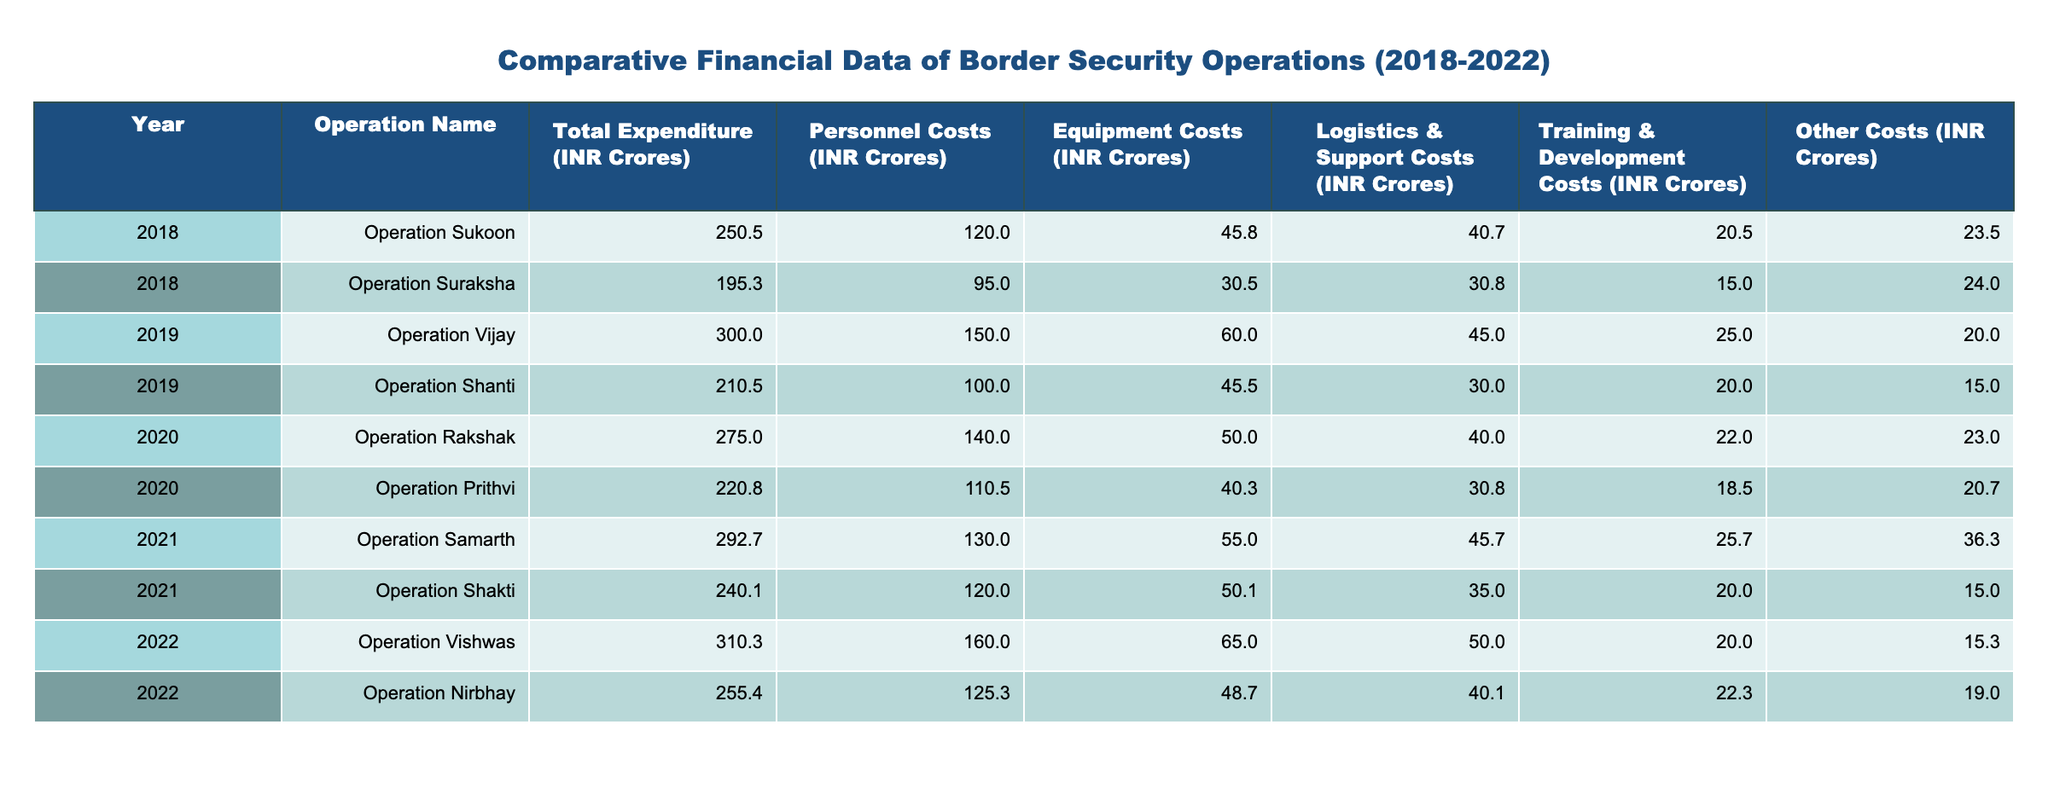What was the total expenditure for Operation Sukoon in 2018? The table indicates that for Operation Sukoon in the year 2018, the total expenditure is listed as 250.5 INR Crores.
Answer: 250.5 INR Crores Which operation had the highest personnel costs in 2022? Reviewing the personnel costs for the year 2022, Operation Vishwas has the highest personnel costs at 160.0 INR Crores compared to Operation Nirbhay which has 125.3 INR Crores.
Answer: Operation Vishwas What is the average equipment cost across all operations from 2018 to 2022? First, I will sum the equipment costs from all operations: 45.8 + 30.5 + 60.0 + 45.5 + 50.0 + 40.3 + 55.0 + 50.1 + 65.0 + 48.7 =  487.9 INR Crores. There are 10 operations, so the average is 487.9 INR / 10 = 48.79 INR Crores.
Answer: 48.79 INR Crores Did the total expenditure for operations decrease from 2019 to 2020? For 2019, the total expenditures are 300.0 (Operation Vijay) + 210.5 (Operation Shanti) = 510.5 INR Crores. For 2020, it is 275.0 (Operation Rakshak) + 220.8 (Operation Prithvi) = 495.8 INR Crores. Since 510.5 > 495.8, the expenditure decreased from 2019 to 2020.
Answer: Yes What was the difference in total expenditure between Operation Nirbhay and Operation Shakti in 2021? From the table, total expenditure for Operation Nirbhay in 2022 is 255.4 INR Crores, and for Operation Shakti in 2021 it is 240.1 INR Crores. The difference is 255.4 - 240.1 = 15.3 INR Crores.
Answer: 15.3 INR Crores Which operation had the lowest total expenditure in 2019? By reviewing the total expenditures for the year 2019, Operation Shanti had an expenditure of 210.5 INR Crores while Operation Vijay had 300.0 INR Crores. Hence, Operation Shanti is the one with the lowest total expenditure for that year.
Answer: Operation Shanti What was the total number of personnel costs from all operations in 2021? I will add the personnel costs from both operations in 2021: 130.0 (Operation Samarth) + 120.0 (Operation Shakti) = 250.0 INR Crores. Thus, the total personnel costs for operations in 2021 are 250.0 INR Crores.
Answer: 250.0 INR Crores Did Operation Rakshak have higher total expenditure than Operation Suraksha? Operation Rakshak's total expenditure in 2020 is 275.0 INR Crores, and Operation Suraksha's total expenditure in 2018 is 195.3 INR Crores. Since 275.0 > 195.3, Operation Rakshak had higher total expenditure.
Answer: Yes 